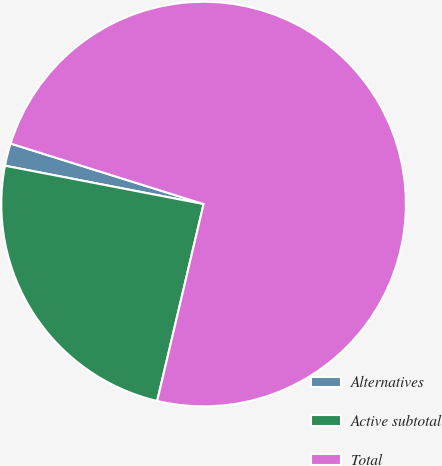<chart> <loc_0><loc_0><loc_500><loc_500><pie_chart><fcel>Alternatives<fcel>Active subtotal<fcel>Total<nl><fcel>1.8%<fcel>24.35%<fcel>73.85%<nl></chart> 